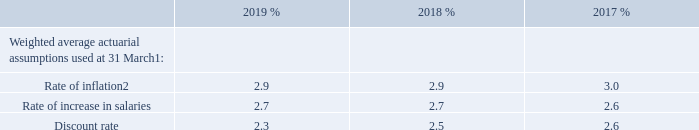Actuarial assumptions
The Group’s scheme liabilities are measured using the projected unit credit method using the principal actuarial assumptions set out below:
Notes: 1 Figures shown represent a weighted average assumption of the individual schemes.
2 The rate of increases in pensions in payment and deferred revaluation are dependent on the rate of inflation.
What does the Weighted average actuarial assumptions consist of? Rate of inflation, rate of increase in salaries, discount rate. How much is the 2019 rate of inflation?
Answer scale should be: percent. 2.9. How much is the 2018 rate of inflation?
Answer scale should be: percent. 2.9. What is the 2019 average rate of inflation?
Answer scale should be: percent. (2.9+2.9)/2
Answer: 2.9. What is the 2019 average rate of increase in salaries?
Answer scale should be: percent. (2.7+2.7)/2
Answer: 2.7. What is the difference between 2019 average rate of inflation and 2019 average rate of increase in salaries?
Answer scale should be: percent. [(2.9+2.9)/2] - [(2.7+2.7)/2]
Answer: 0.2. 